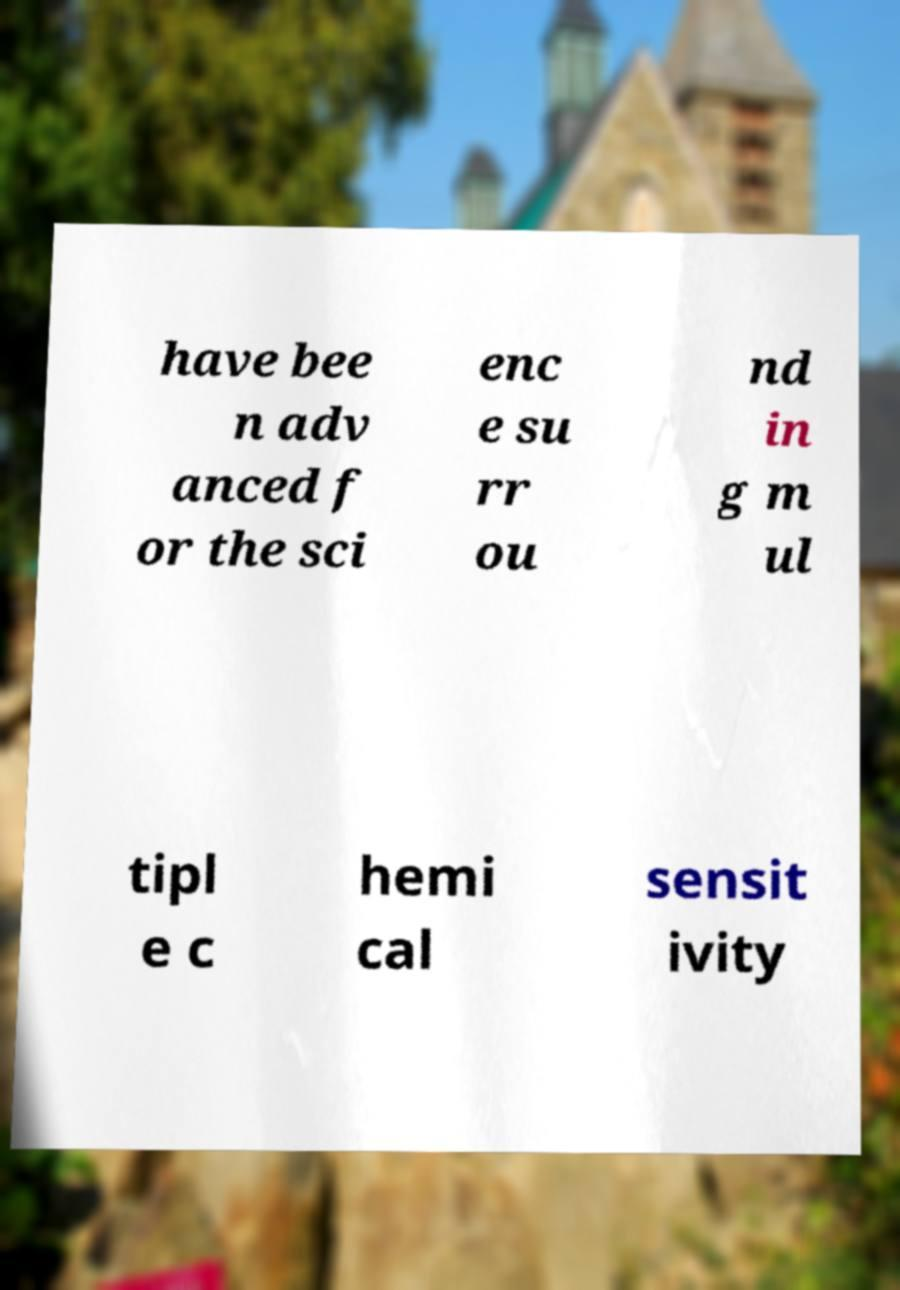Please read and relay the text visible in this image. What does it say? have bee n adv anced f or the sci enc e su rr ou nd in g m ul tipl e c hemi cal sensit ivity 